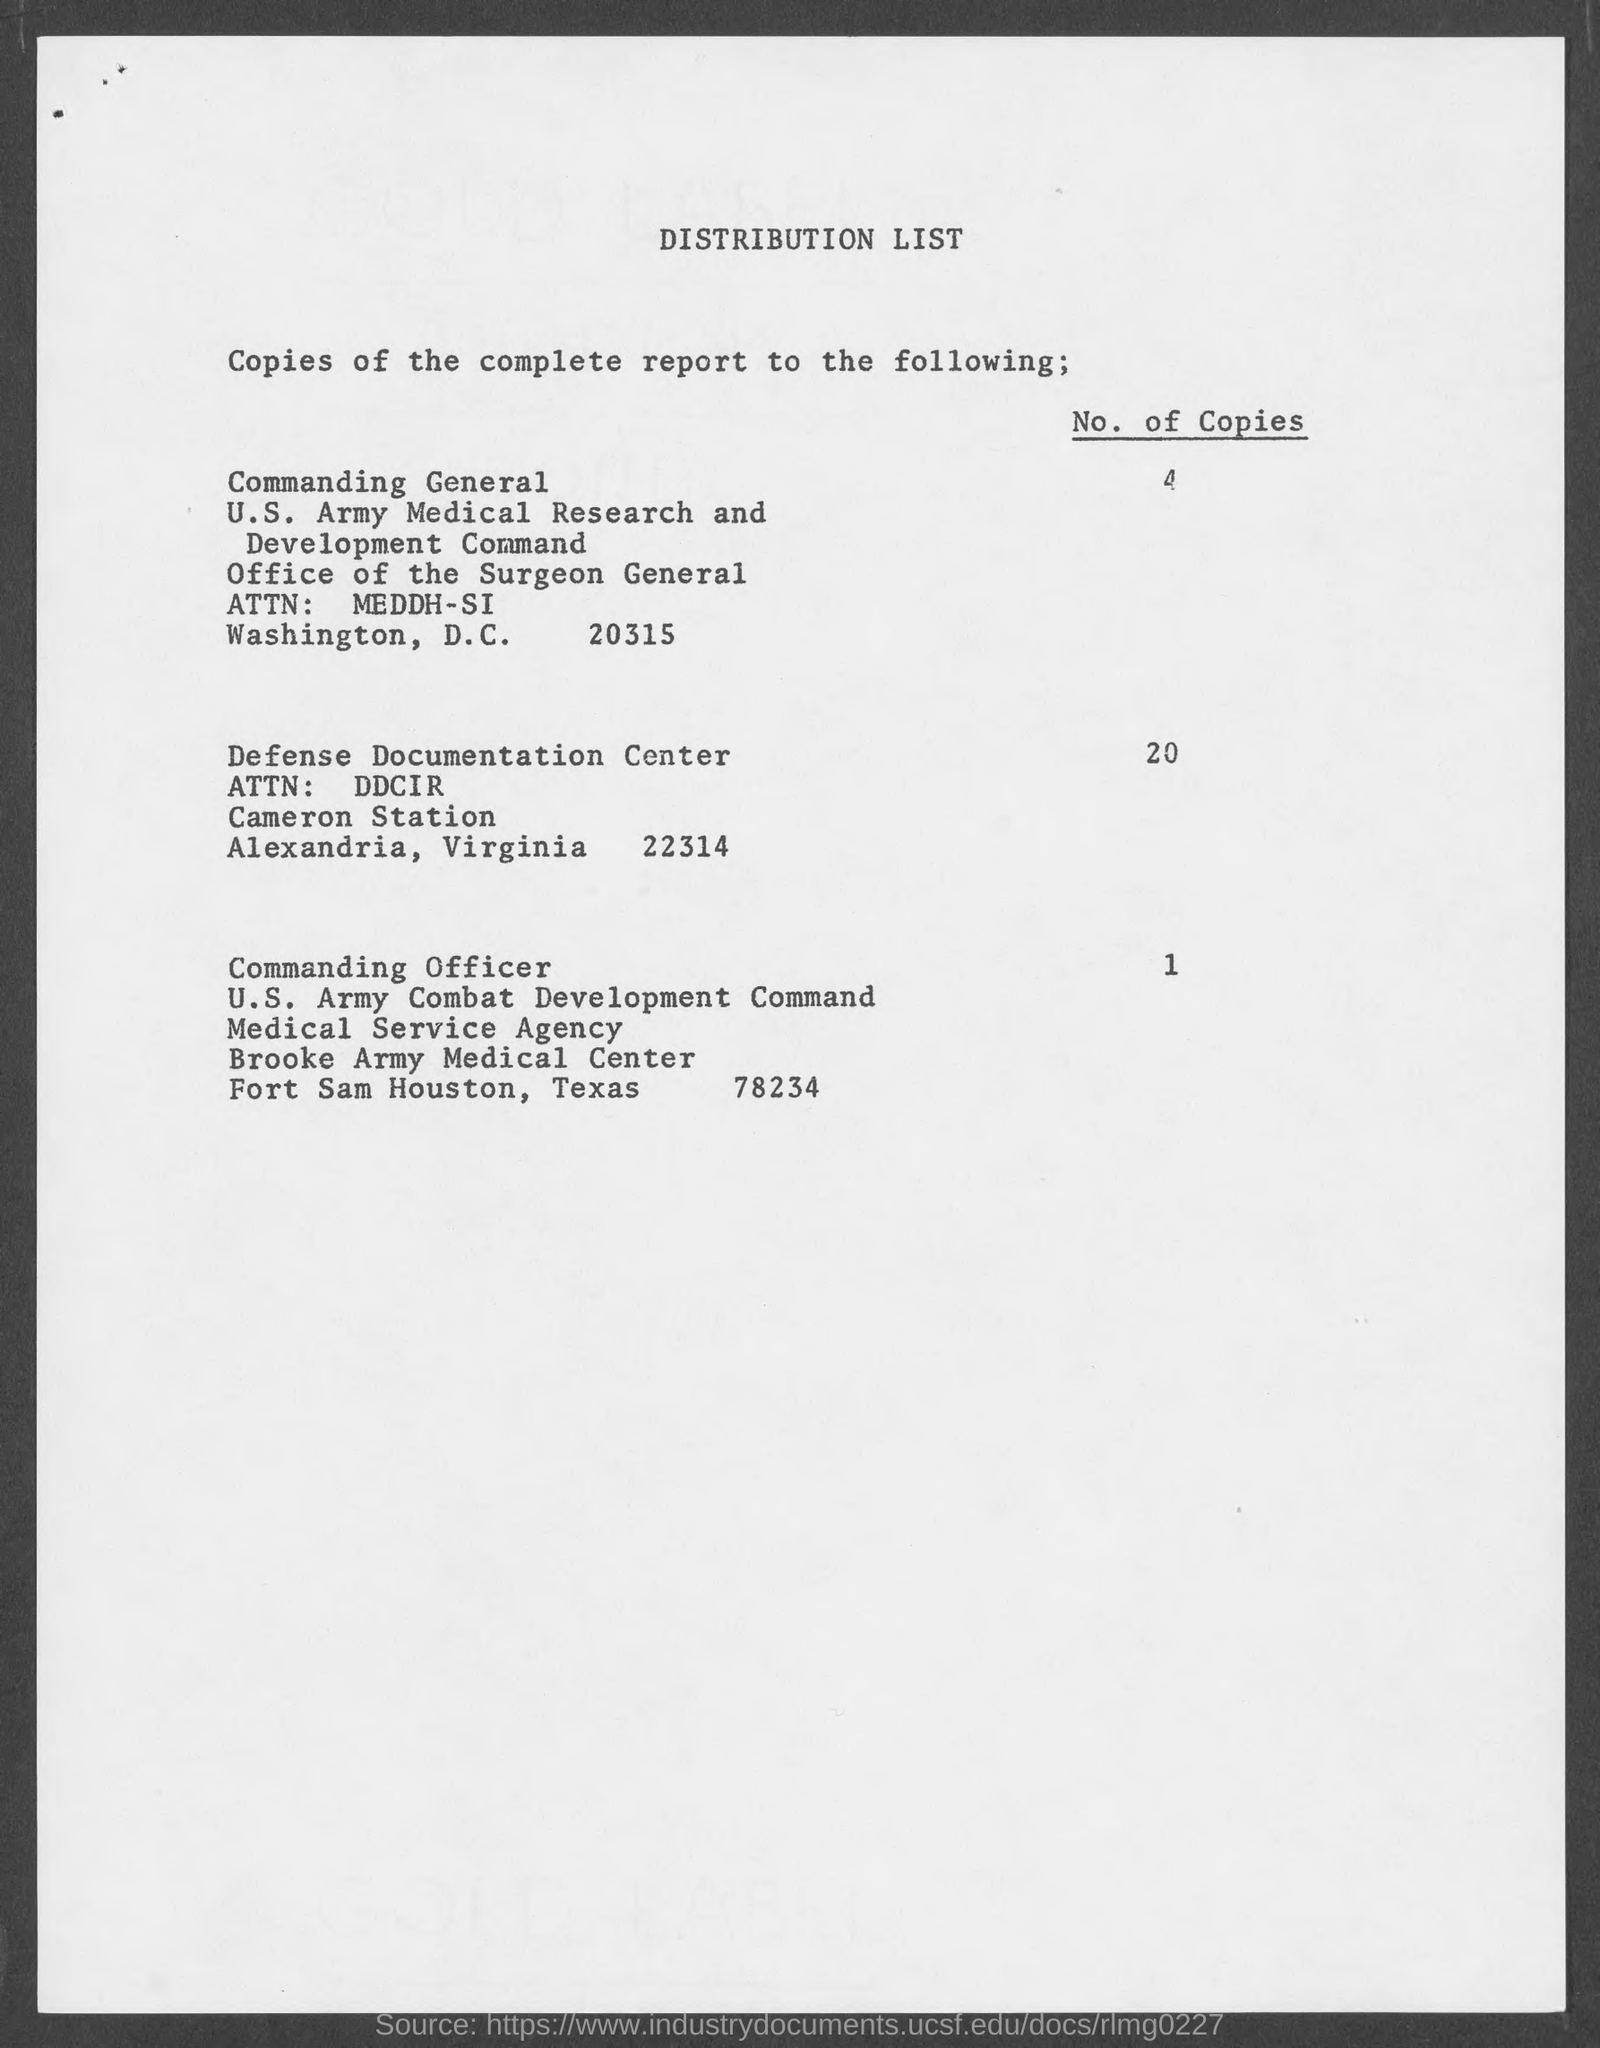How many no. of copies are distributed to commanding general?
Offer a terse response. 4. What is the heading of the page?
Keep it short and to the point. Distribution list. How many no. of copies are distributed to defense documentation center?
Your answer should be compact. 20. How many no. of copies are distributed to commanding officer?
Offer a terse response. 1. In which county is defense documentation center at?
Your response must be concise. Alexandria. 